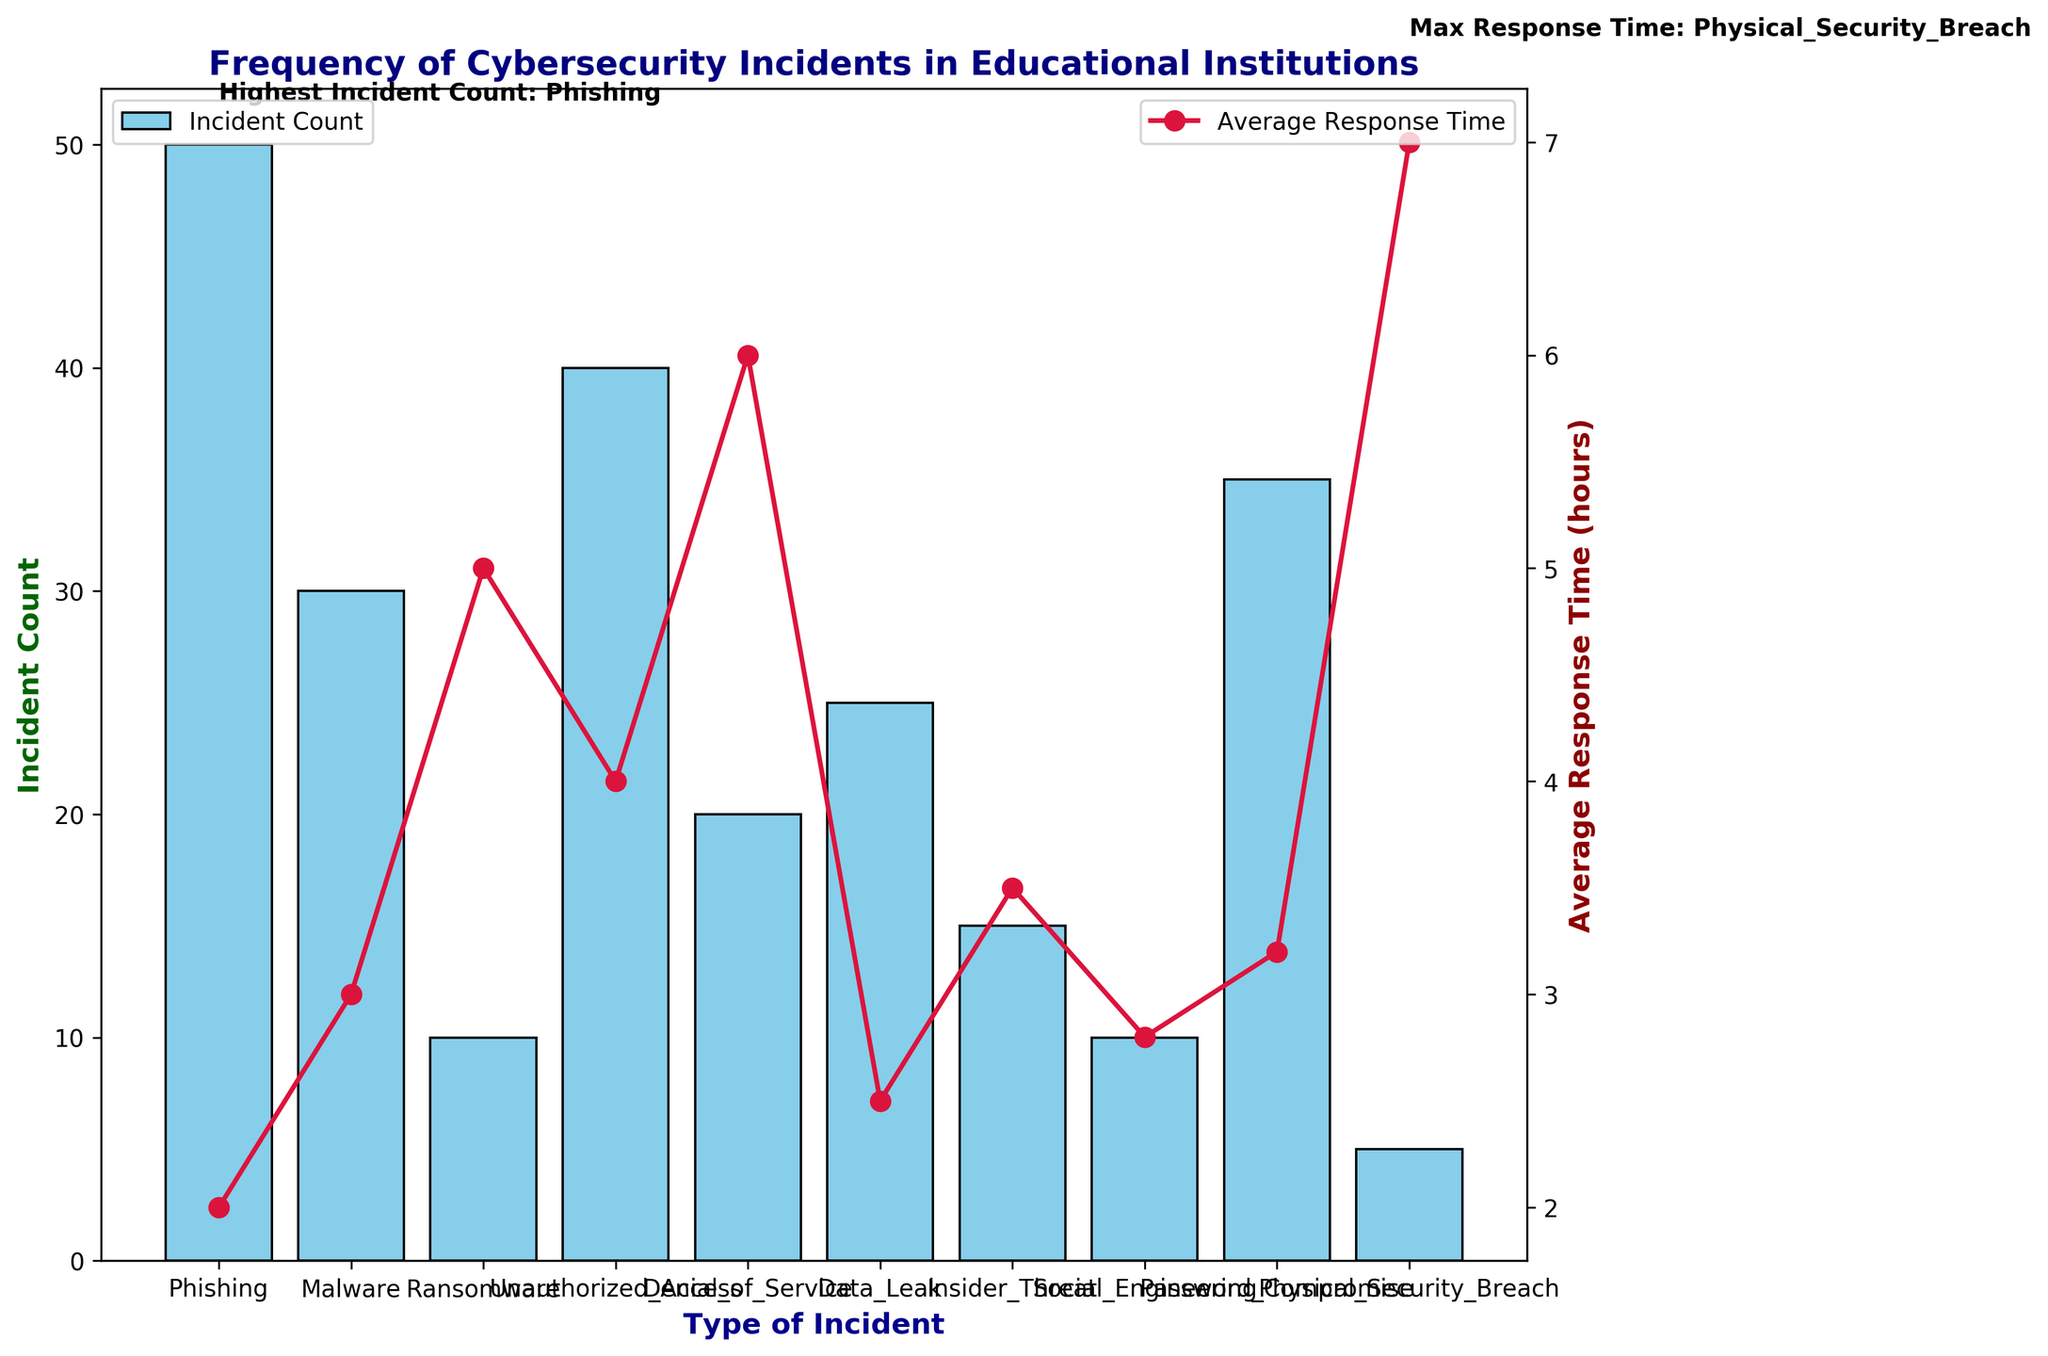What type of incident has the highest count? The highest count is determined by looking at the tallest bar in the bar chart. The label on this bar indicates the type of incident.
Answer: Phishing Which cybersecurity incident type has the longest average response time? The longest average response time can be found by identifying the highest point on the line plot and checking the corresponding x-axis label.
Answer: Physical_Security_Breach How many types of incidents have an average response time above 4 hours? Count the number of points on the line plot that are above the 4-hour mark on the y-axis.
Answer: 3 What type of incident has both a count above 30 and an average response time below 4 hours? Identify bars with heights above 30 and check if the corresponding points on the line plot lie below the 4-hour mark.
Answer: Phishing, Password_Compromise How much higher is the count of Phishing incidents compared to Ransomware incidents? Subtract the Ransomware incident count from the Phishing incident count.
Answer: 40 Which has a higher incident count: Unauthorized_Access or Denial_of_Service? Compare the heights of the bars for Unauthorized_Access and Denial_of_Service.
Answer: Unauthorized_Access What is the average response time for incidents with counts below 25? Identify incidents with counts below 25, sum their average response times, and divide by the number of such incidents. Types below 25 counts: Ransomware, Denial_of_Service, Data_Leak, Insider_Threat, Social_Engineering, Physical_Security_Breach. Average response time is (5 + 6 + 2.5 + 3.5 + 2.8 + 7) / 6.
Answer: 4.13 Compare the incident counts of Social_Engineering and Data_Leak. Which is higher? Look at the heights of the bars for Social_Engineering and Data_Leak.
Answer: Data_Leak Which type of incident with an average response time below 3 hours has the second highest count? First, filter incidents with average response times below 3 hours, then identify the one with the second highest bar.
Answer: Data_Leak 